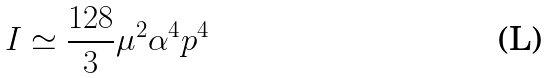Convert formula to latex. <formula><loc_0><loc_0><loc_500><loc_500>I \simeq \frac { 1 2 8 } { 3 } \mu ^ { 2 } \alpha ^ { 4 } p ^ { 4 }</formula> 